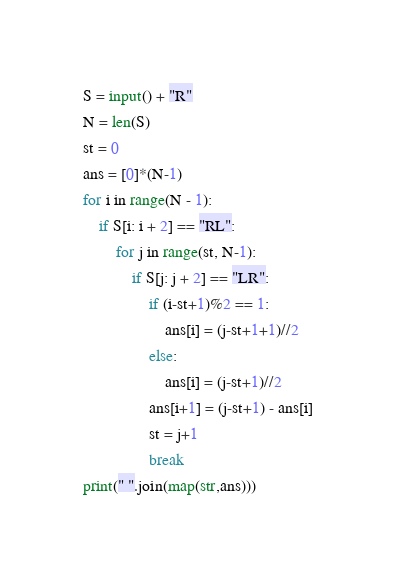Convert code to text. <code><loc_0><loc_0><loc_500><loc_500><_Python_>S = input() + "R"
N = len(S)
st = 0
ans = [0]*(N-1)
for i in range(N - 1):
    if S[i: i + 2] == "RL":
        for j in range(st, N-1):
            if S[j: j + 2] == "LR":
                if (i-st+1)%2 == 1:
                    ans[i] = (j-st+1+1)//2
                else:
                    ans[i] = (j-st+1)//2
                ans[i+1] = (j-st+1) - ans[i]
                st = j+1
                break
print(" ".join(map(str,ans)))</code> 